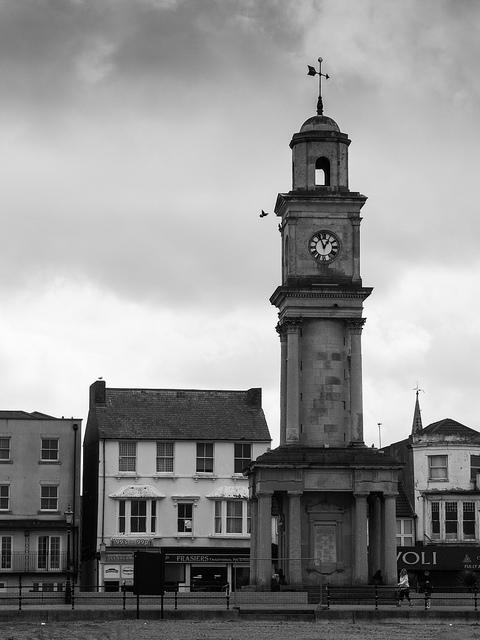What is the name for the cross shaped structure on top of the tower?

Choices:
A) field thermometer
B) weather vane
C) tungsten cross
D) metric barometer weather vane 